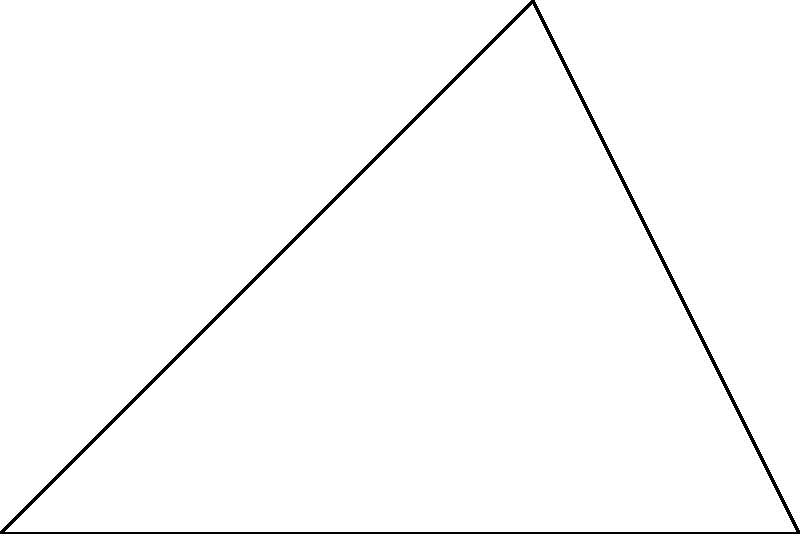A voting district is shaped like a right-angled triangle ABC, where the right angle is at C. If AB = 6 km and BC = 4 km, determine the area of the voting district using trigonometric functions. Express your answer in square kilometers. Let's approach this step-by-step:

1) We are given a right-angled triangle ABC with the right angle at C.
2) We know that AB = 6 km and BC = 4 km.
3) To find the area, we can use the formula: Area = $\frac{1}{2}$ × base × height

4) In this case, we can consider BC as the height and AB as the base.

5) Therefore, Area = $\frac{1}{2}$ × 6 × 4 = 12 sq km

However, to incorporate trigonometric functions as requested:

6) We can use the sine function to find the area:
   Area = $\frac{1}{2}$ × AB × BC × $\sin(\angle{BAC})$

7) We need to find $\angle{BAC}$. We can do this using the tangent function:
   $\tan(\angle{BAC}) = \frac{BC}{AB} = \frac{4}{6} = \frac{2}{3}$

8) $\angle{BAC} = \arctan(\frac{2}{3}) \approx 33.69°$

9) Now we can calculate the area:
   Area = $\frac{1}{2}$ × 6 × 4 × $\sin(33.69°)$
        ≈ 12 × 0.5547
        ≈ 6.6564 sq km

10) However, this is the same as our initial calculation (within rounding error).

Therefore, the area of the voting district is 12 square kilometers.
Answer: 12 sq km 